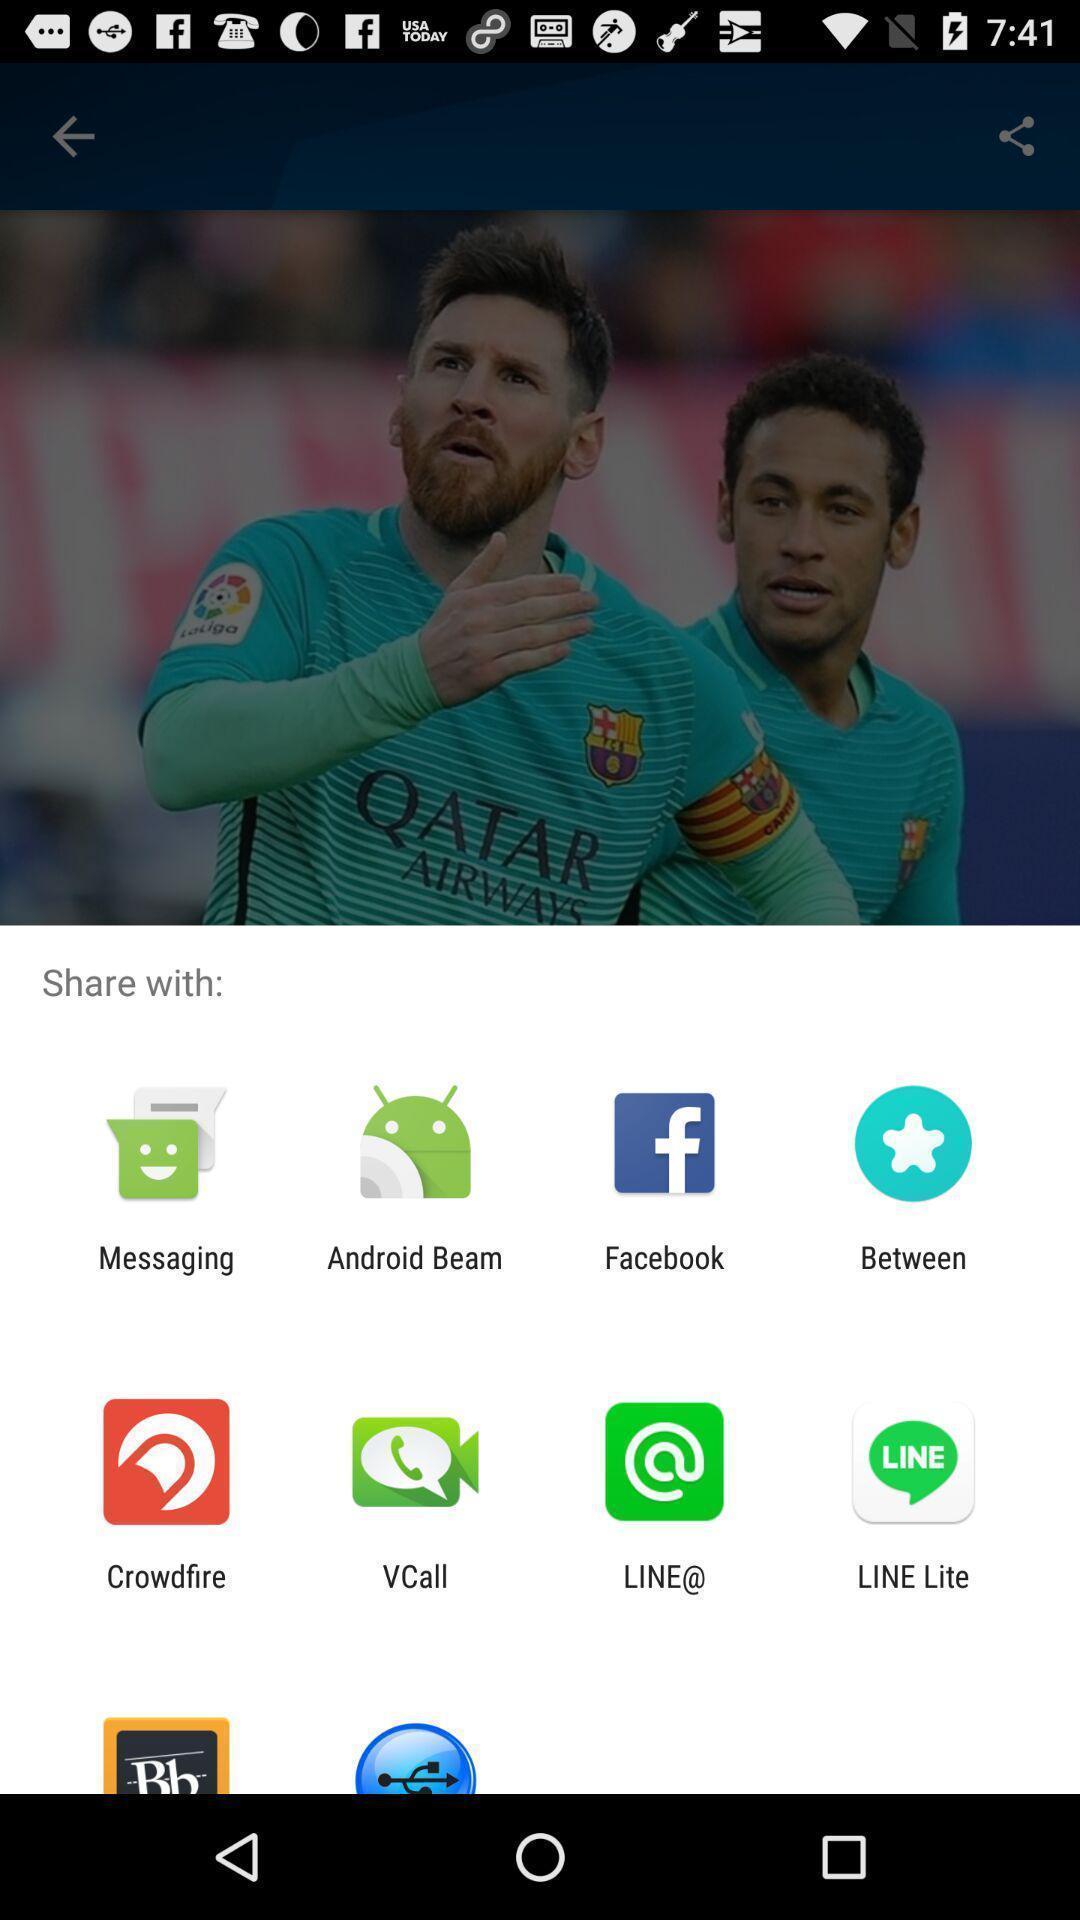Please provide a description for this image. Share pop up with list of sharing options. 